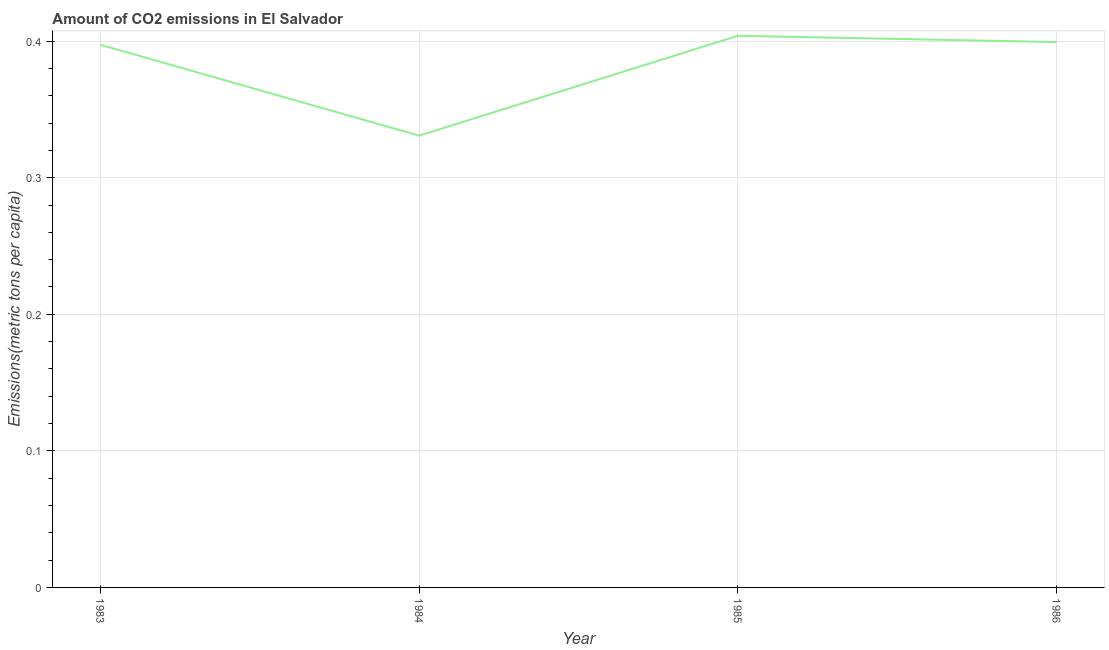What is the amount of co2 emissions in 1984?
Your response must be concise. 0.33. Across all years, what is the maximum amount of co2 emissions?
Offer a very short reply. 0.4. Across all years, what is the minimum amount of co2 emissions?
Keep it short and to the point. 0.33. What is the sum of the amount of co2 emissions?
Give a very brief answer. 1.53. What is the difference between the amount of co2 emissions in 1985 and 1986?
Ensure brevity in your answer.  0. What is the average amount of co2 emissions per year?
Make the answer very short. 0.38. What is the median amount of co2 emissions?
Keep it short and to the point. 0.4. What is the ratio of the amount of co2 emissions in 1985 to that in 1986?
Your answer should be compact. 1.01. Is the amount of co2 emissions in 1983 less than that in 1985?
Keep it short and to the point. Yes. What is the difference between the highest and the second highest amount of co2 emissions?
Ensure brevity in your answer.  0. What is the difference between the highest and the lowest amount of co2 emissions?
Your response must be concise. 0.07. In how many years, is the amount of co2 emissions greater than the average amount of co2 emissions taken over all years?
Ensure brevity in your answer.  3. Does the amount of co2 emissions monotonically increase over the years?
Your answer should be compact. No. Does the graph contain any zero values?
Provide a succinct answer. No. What is the title of the graph?
Provide a short and direct response. Amount of CO2 emissions in El Salvador. What is the label or title of the Y-axis?
Make the answer very short. Emissions(metric tons per capita). What is the Emissions(metric tons per capita) in 1983?
Your response must be concise. 0.4. What is the Emissions(metric tons per capita) in 1984?
Offer a terse response. 0.33. What is the Emissions(metric tons per capita) in 1985?
Offer a terse response. 0.4. What is the Emissions(metric tons per capita) of 1986?
Provide a short and direct response. 0.4. What is the difference between the Emissions(metric tons per capita) in 1983 and 1984?
Ensure brevity in your answer.  0.07. What is the difference between the Emissions(metric tons per capita) in 1983 and 1985?
Offer a very short reply. -0.01. What is the difference between the Emissions(metric tons per capita) in 1983 and 1986?
Provide a succinct answer. -0. What is the difference between the Emissions(metric tons per capita) in 1984 and 1985?
Your response must be concise. -0.07. What is the difference between the Emissions(metric tons per capita) in 1984 and 1986?
Provide a short and direct response. -0.07. What is the difference between the Emissions(metric tons per capita) in 1985 and 1986?
Give a very brief answer. 0. What is the ratio of the Emissions(metric tons per capita) in 1983 to that in 1984?
Offer a very short reply. 1.2. What is the ratio of the Emissions(metric tons per capita) in 1983 to that in 1985?
Your answer should be compact. 0.98. What is the ratio of the Emissions(metric tons per capita) in 1983 to that in 1986?
Keep it short and to the point. 0.99. What is the ratio of the Emissions(metric tons per capita) in 1984 to that in 1985?
Your answer should be very brief. 0.82. What is the ratio of the Emissions(metric tons per capita) in 1984 to that in 1986?
Offer a terse response. 0.83. 